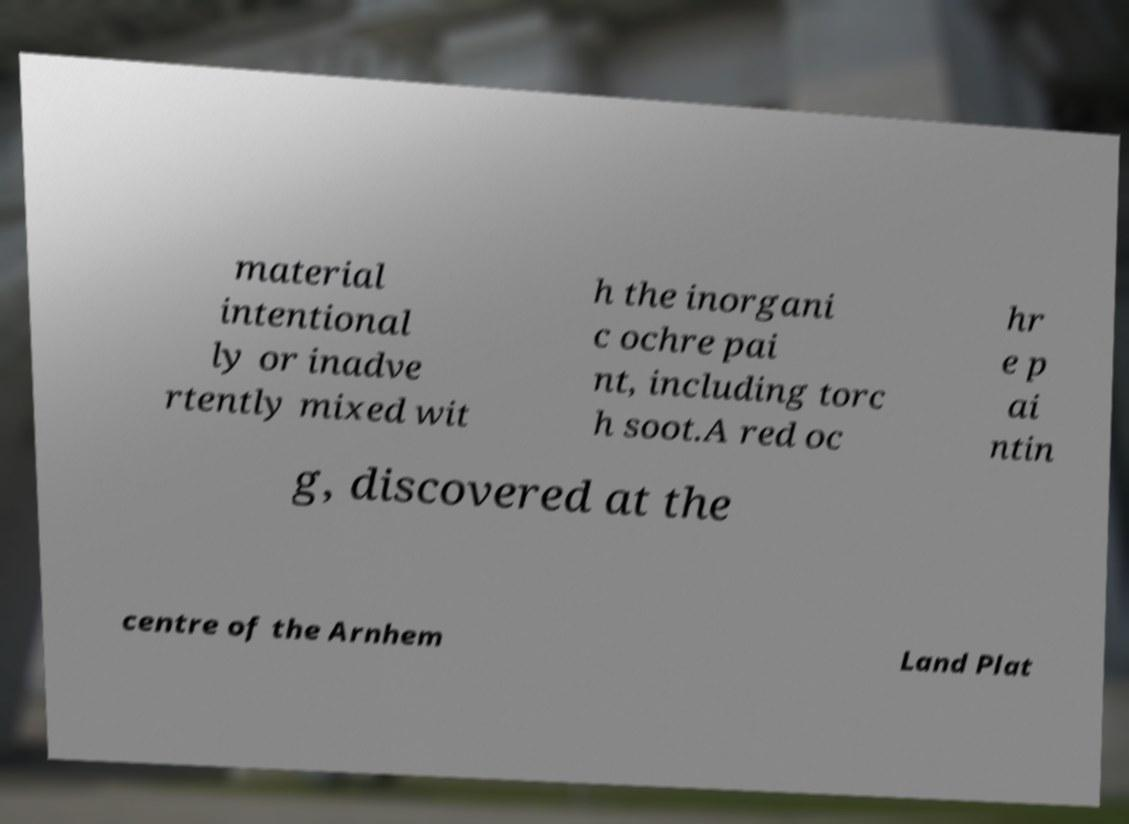Can you accurately transcribe the text from the provided image for me? material intentional ly or inadve rtently mixed wit h the inorgani c ochre pai nt, including torc h soot.A red oc hr e p ai ntin g, discovered at the centre of the Arnhem Land Plat 